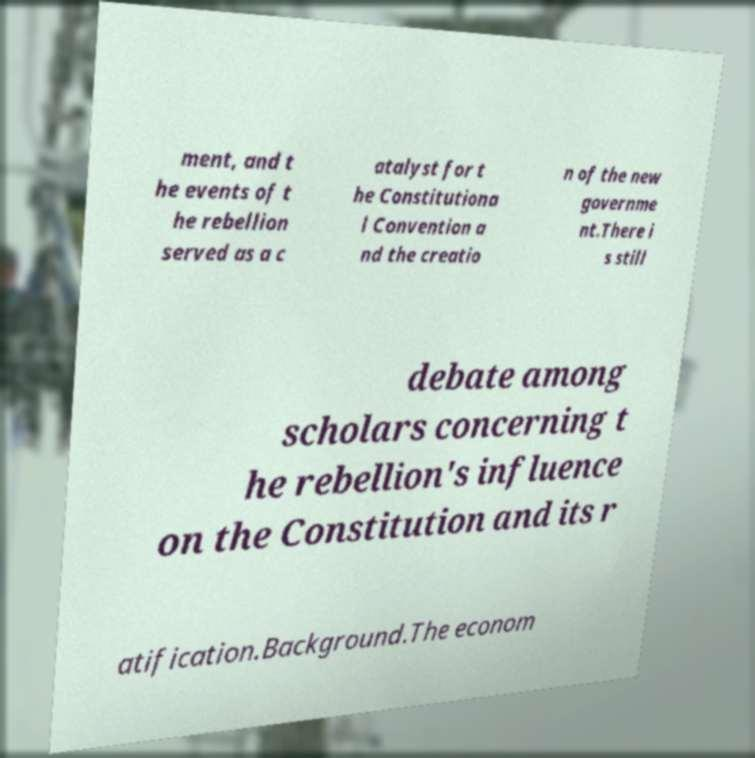Please identify and transcribe the text found in this image. ment, and t he events of t he rebellion served as a c atalyst for t he Constitutiona l Convention a nd the creatio n of the new governme nt.There i s still debate among scholars concerning t he rebellion's influence on the Constitution and its r atification.Background.The econom 